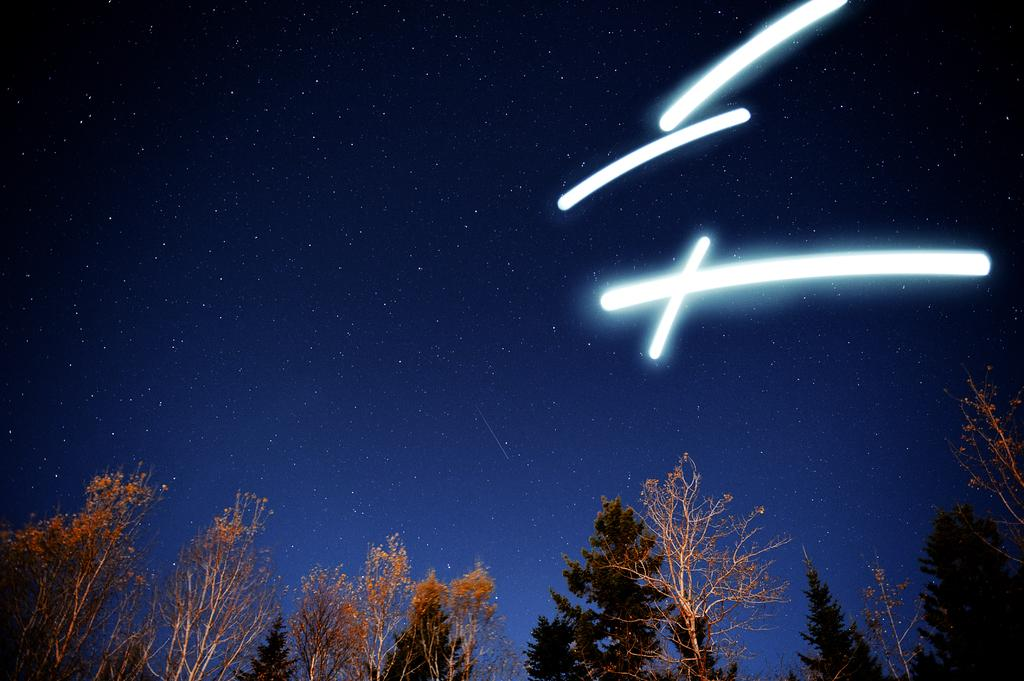What type of natural elements can be seen in the image? There are trees in the image. What part of the natural environment is visible in the image? The sky is visible in the image. Can you describe any man-made elements in the image? There are light lines in the image. What type of operation is being performed on the shirt in the image? There is no shirt or operation present in the image. What is the name of the person wearing the shirt in the image? There is no person or shirt present in the image, so it is not possible to determine the name of the person. 